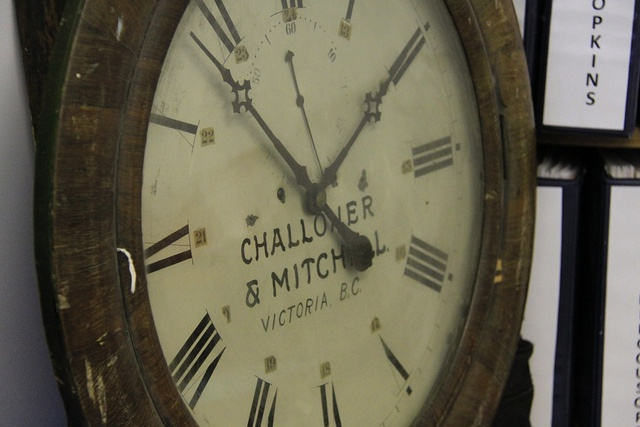Describe the objects in this image and their specific colors. I can see clock in darkgray, gray, darkgreen, and black tones, book in darkgray, black, and lightgray tones, and book in darkgray, black, and gray tones in this image. 